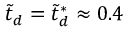<formula> <loc_0><loc_0><loc_500><loc_500>\tilde { t } _ { d } = \tilde { t } _ { d } ^ { * } \approx 0 . 4</formula> 